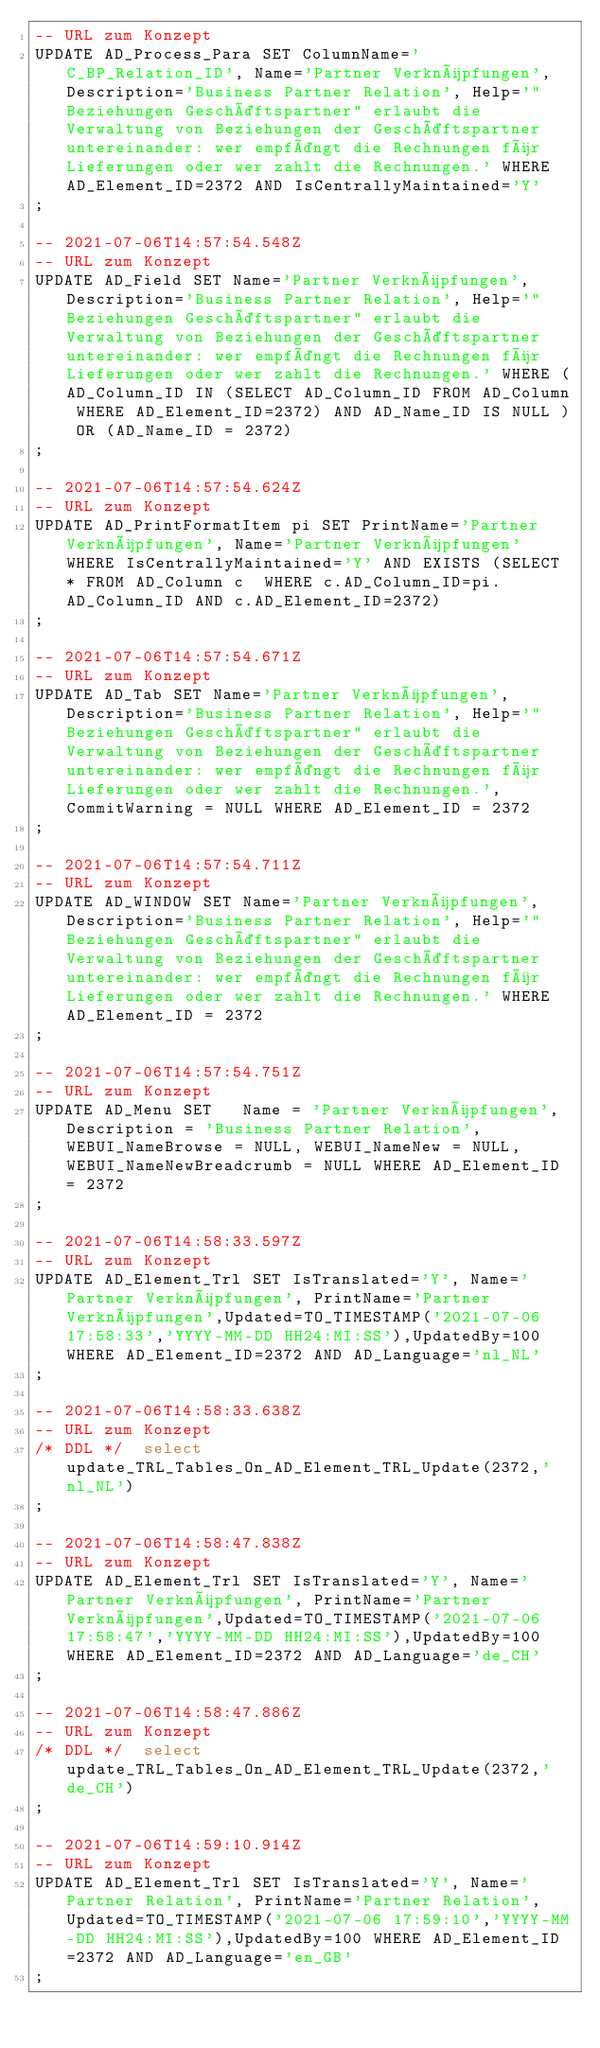Convert code to text. <code><loc_0><loc_0><loc_500><loc_500><_SQL_>-- URL zum Konzept
UPDATE AD_Process_Para SET ColumnName='C_BP_Relation_ID', Name='Partner Verknüpfungen', Description='Business Partner Relation', Help='"Beziehungen Geschäftspartner" erlaubt die Verwaltung von Beziehungen der Geschäftspartner untereinander: wer empfängt die Rechnungen für Lieferungen oder wer zahlt die Rechnungen.' WHERE AD_Element_ID=2372 AND IsCentrallyMaintained='Y'
;

-- 2021-07-06T14:57:54.548Z
-- URL zum Konzept
UPDATE AD_Field SET Name='Partner Verknüpfungen', Description='Business Partner Relation', Help='"Beziehungen Geschäftspartner" erlaubt die Verwaltung von Beziehungen der Geschäftspartner untereinander: wer empfängt die Rechnungen für Lieferungen oder wer zahlt die Rechnungen.' WHERE (AD_Column_ID IN (SELECT AD_Column_ID FROM AD_Column WHERE AD_Element_ID=2372) AND AD_Name_ID IS NULL ) OR (AD_Name_ID = 2372)
;

-- 2021-07-06T14:57:54.624Z
-- URL zum Konzept
UPDATE AD_PrintFormatItem pi SET PrintName='Partner Verknüpfungen', Name='Partner Verknüpfungen' WHERE IsCentrallyMaintained='Y' AND EXISTS (SELECT * FROM AD_Column c  WHERE c.AD_Column_ID=pi.AD_Column_ID AND c.AD_Element_ID=2372)
;

-- 2021-07-06T14:57:54.671Z
-- URL zum Konzept
UPDATE AD_Tab SET Name='Partner Verknüpfungen', Description='Business Partner Relation', Help='"Beziehungen Geschäftspartner" erlaubt die Verwaltung von Beziehungen der Geschäftspartner untereinander: wer empfängt die Rechnungen für Lieferungen oder wer zahlt die Rechnungen.', CommitWarning = NULL WHERE AD_Element_ID = 2372
;

-- 2021-07-06T14:57:54.711Z
-- URL zum Konzept
UPDATE AD_WINDOW SET Name='Partner Verknüpfungen', Description='Business Partner Relation', Help='"Beziehungen Geschäftspartner" erlaubt die Verwaltung von Beziehungen der Geschäftspartner untereinander: wer empfängt die Rechnungen für Lieferungen oder wer zahlt die Rechnungen.' WHERE AD_Element_ID = 2372
;

-- 2021-07-06T14:57:54.751Z
-- URL zum Konzept
UPDATE AD_Menu SET   Name = 'Partner Verknüpfungen', Description = 'Business Partner Relation', WEBUI_NameBrowse = NULL, WEBUI_NameNew = NULL, WEBUI_NameNewBreadcrumb = NULL WHERE AD_Element_ID = 2372
;

-- 2021-07-06T14:58:33.597Z
-- URL zum Konzept
UPDATE AD_Element_Trl SET IsTranslated='Y', Name='Partner Verknüpfungen', PrintName='Partner Verknüpfungen',Updated=TO_TIMESTAMP('2021-07-06 17:58:33','YYYY-MM-DD HH24:MI:SS'),UpdatedBy=100 WHERE AD_Element_ID=2372 AND AD_Language='nl_NL'
;

-- 2021-07-06T14:58:33.638Z
-- URL zum Konzept
/* DDL */  select update_TRL_Tables_On_AD_Element_TRL_Update(2372,'nl_NL')
;

-- 2021-07-06T14:58:47.838Z
-- URL zum Konzept
UPDATE AD_Element_Trl SET IsTranslated='Y', Name='Partner Verknüpfungen', PrintName='Partner Verknüpfungen',Updated=TO_TIMESTAMP('2021-07-06 17:58:47','YYYY-MM-DD HH24:MI:SS'),UpdatedBy=100 WHERE AD_Element_ID=2372 AND AD_Language='de_CH'
;

-- 2021-07-06T14:58:47.886Z
-- URL zum Konzept
/* DDL */  select update_TRL_Tables_On_AD_Element_TRL_Update(2372,'de_CH')
;

-- 2021-07-06T14:59:10.914Z
-- URL zum Konzept
UPDATE AD_Element_Trl SET IsTranslated='Y', Name='Partner Relation', PrintName='Partner Relation',Updated=TO_TIMESTAMP('2021-07-06 17:59:10','YYYY-MM-DD HH24:MI:SS'),UpdatedBy=100 WHERE AD_Element_ID=2372 AND AD_Language='en_GB'
;
</code> 